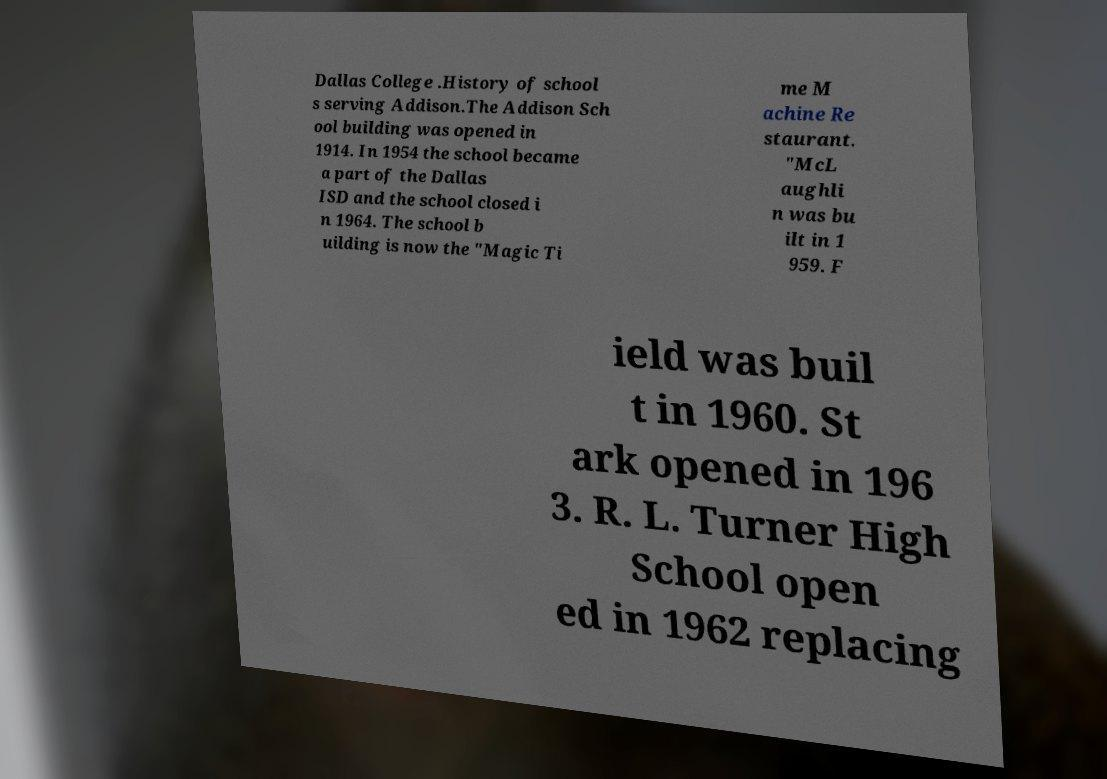Please read and relay the text visible in this image. What does it say? Dallas College .History of school s serving Addison.The Addison Sch ool building was opened in 1914. In 1954 the school became a part of the Dallas ISD and the school closed i n 1964. The school b uilding is now the "Magic Ti me M achine Re staurant. "McL aughli n was bu ilt in 1 959. F ield was buil t in 1960. St ark opened in 196 3. R. L. Turner High School open ed in 1962 replacing 